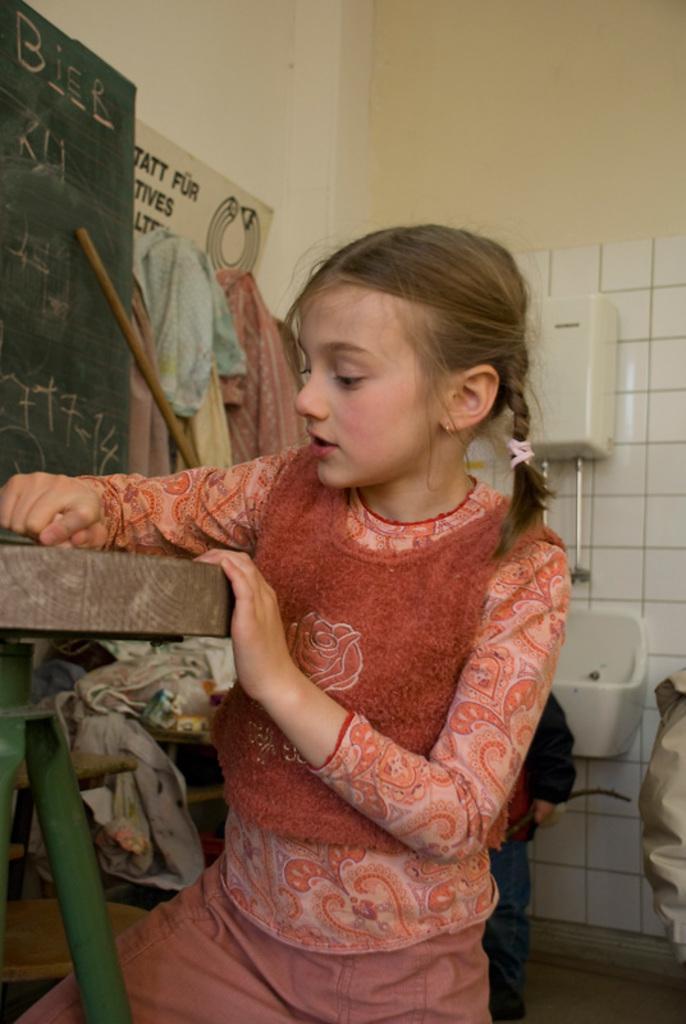Describe this image in one or two sentences. In this image we can see a girl. She is wearing orange color dress, beside her one table is there and and one board is there. Back of her a tile wall is present and clothes are attached to the wall. 